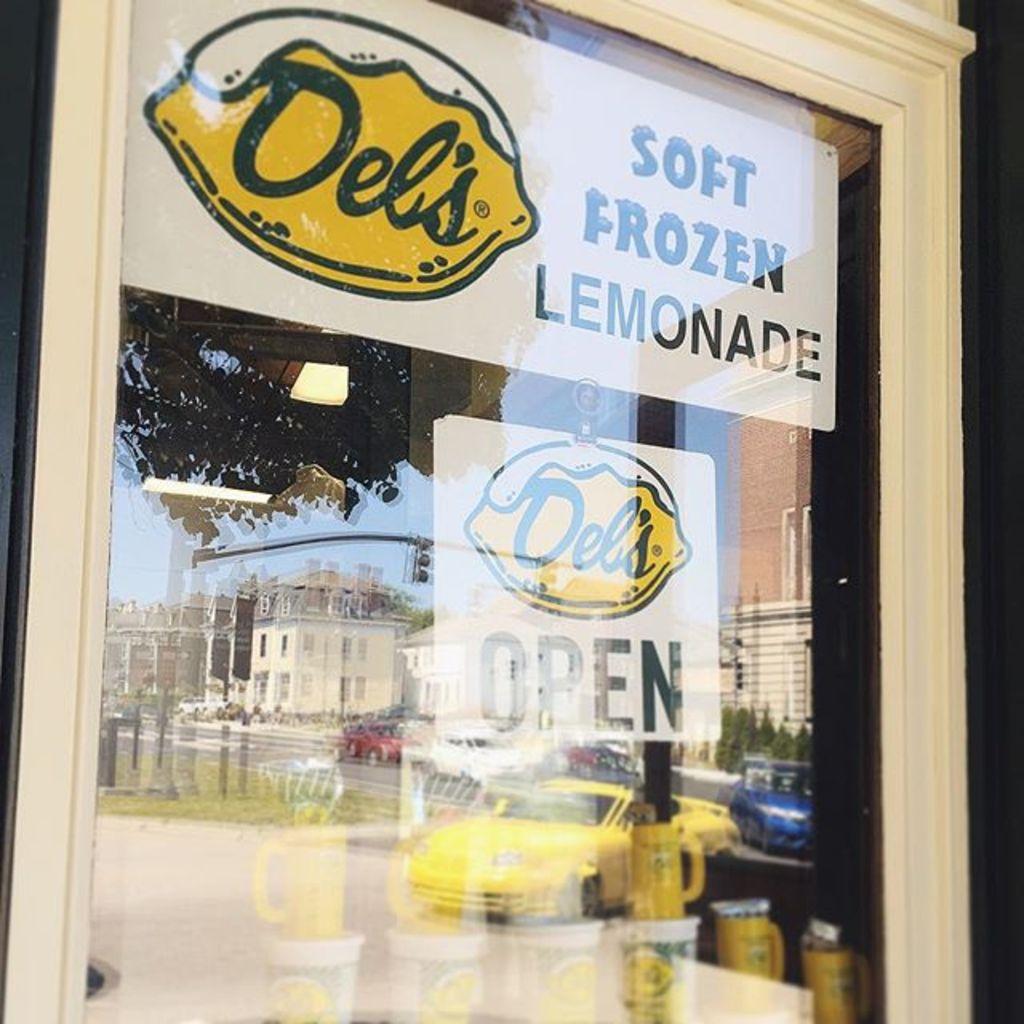What is the name of this business?
Your response must be concise. Del's. What brand of soft frozen lemonade?
Your answer should be very brief. Del's. 